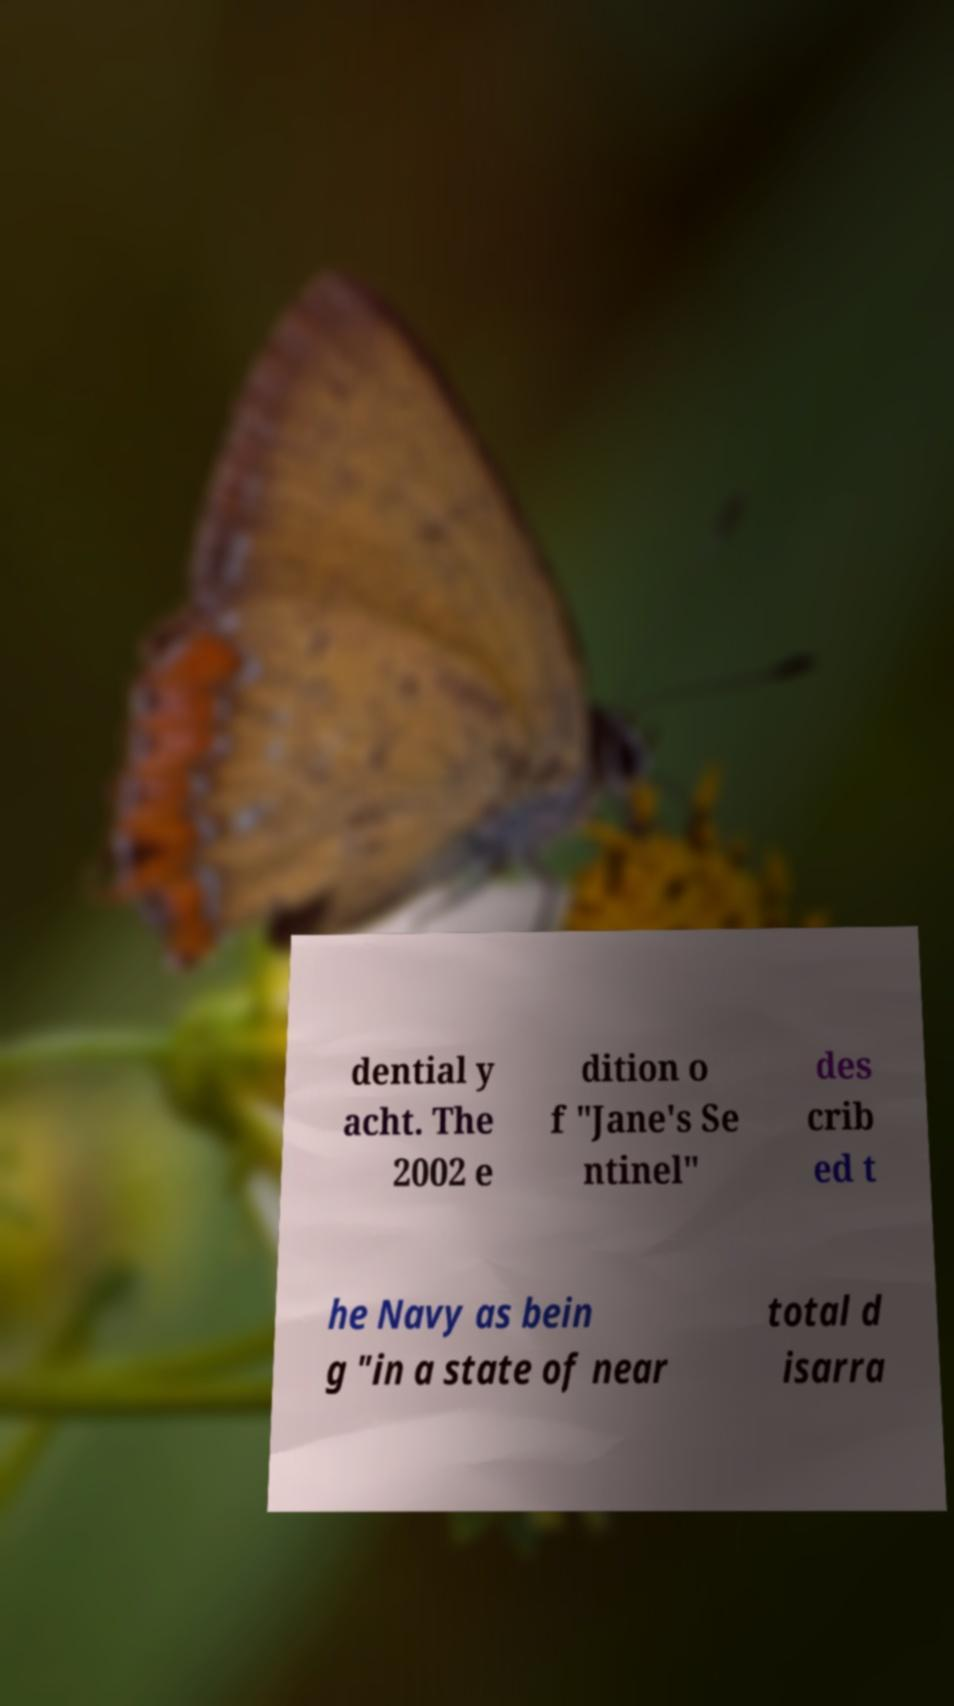Could you assist in decoding the text presented in this image and type it out clearly? dential y acht. The 2002 e dition o f "Jane's Se ntinel" des crib ed t he Navy as bein g "in a state of near total d isarra 